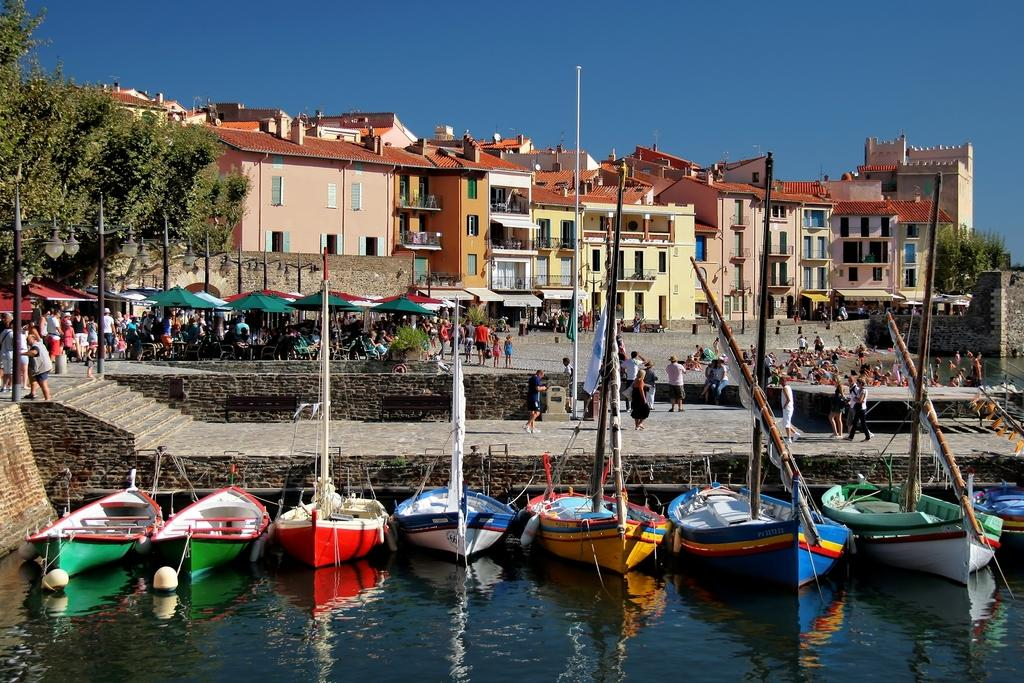Who or what can be seen in the image? There are people in the image. What type of structures are present in the image? There are buildings, shops, and poles in the image. What natural elements can be seen in the image? There are trees and boats in the water in the image. What architectural features are visible in the image? There are stairs in the image. What part of the natural environment is visible in the image? The sky is visible in the image. Is there a trail leading to the bridge in the image? There is no trail or bridge present in the image. What process is being carried out by the people in the image? The image does not provide enough information to determine any specific process being carried out by the people. 